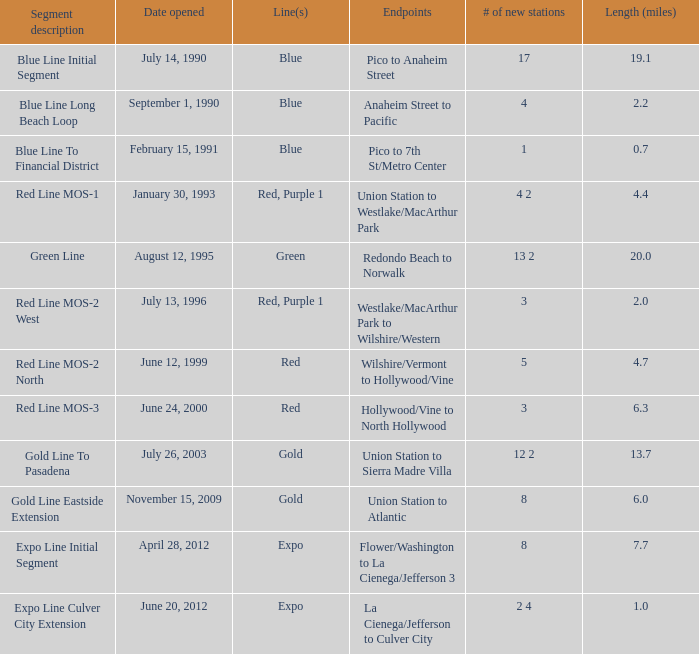How many news channels were launched on june 24, 2000? 3.0. 